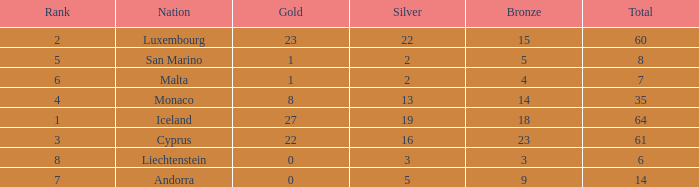How many bronzes for nations with over 22 golds and ranked under 2? 18.0. 